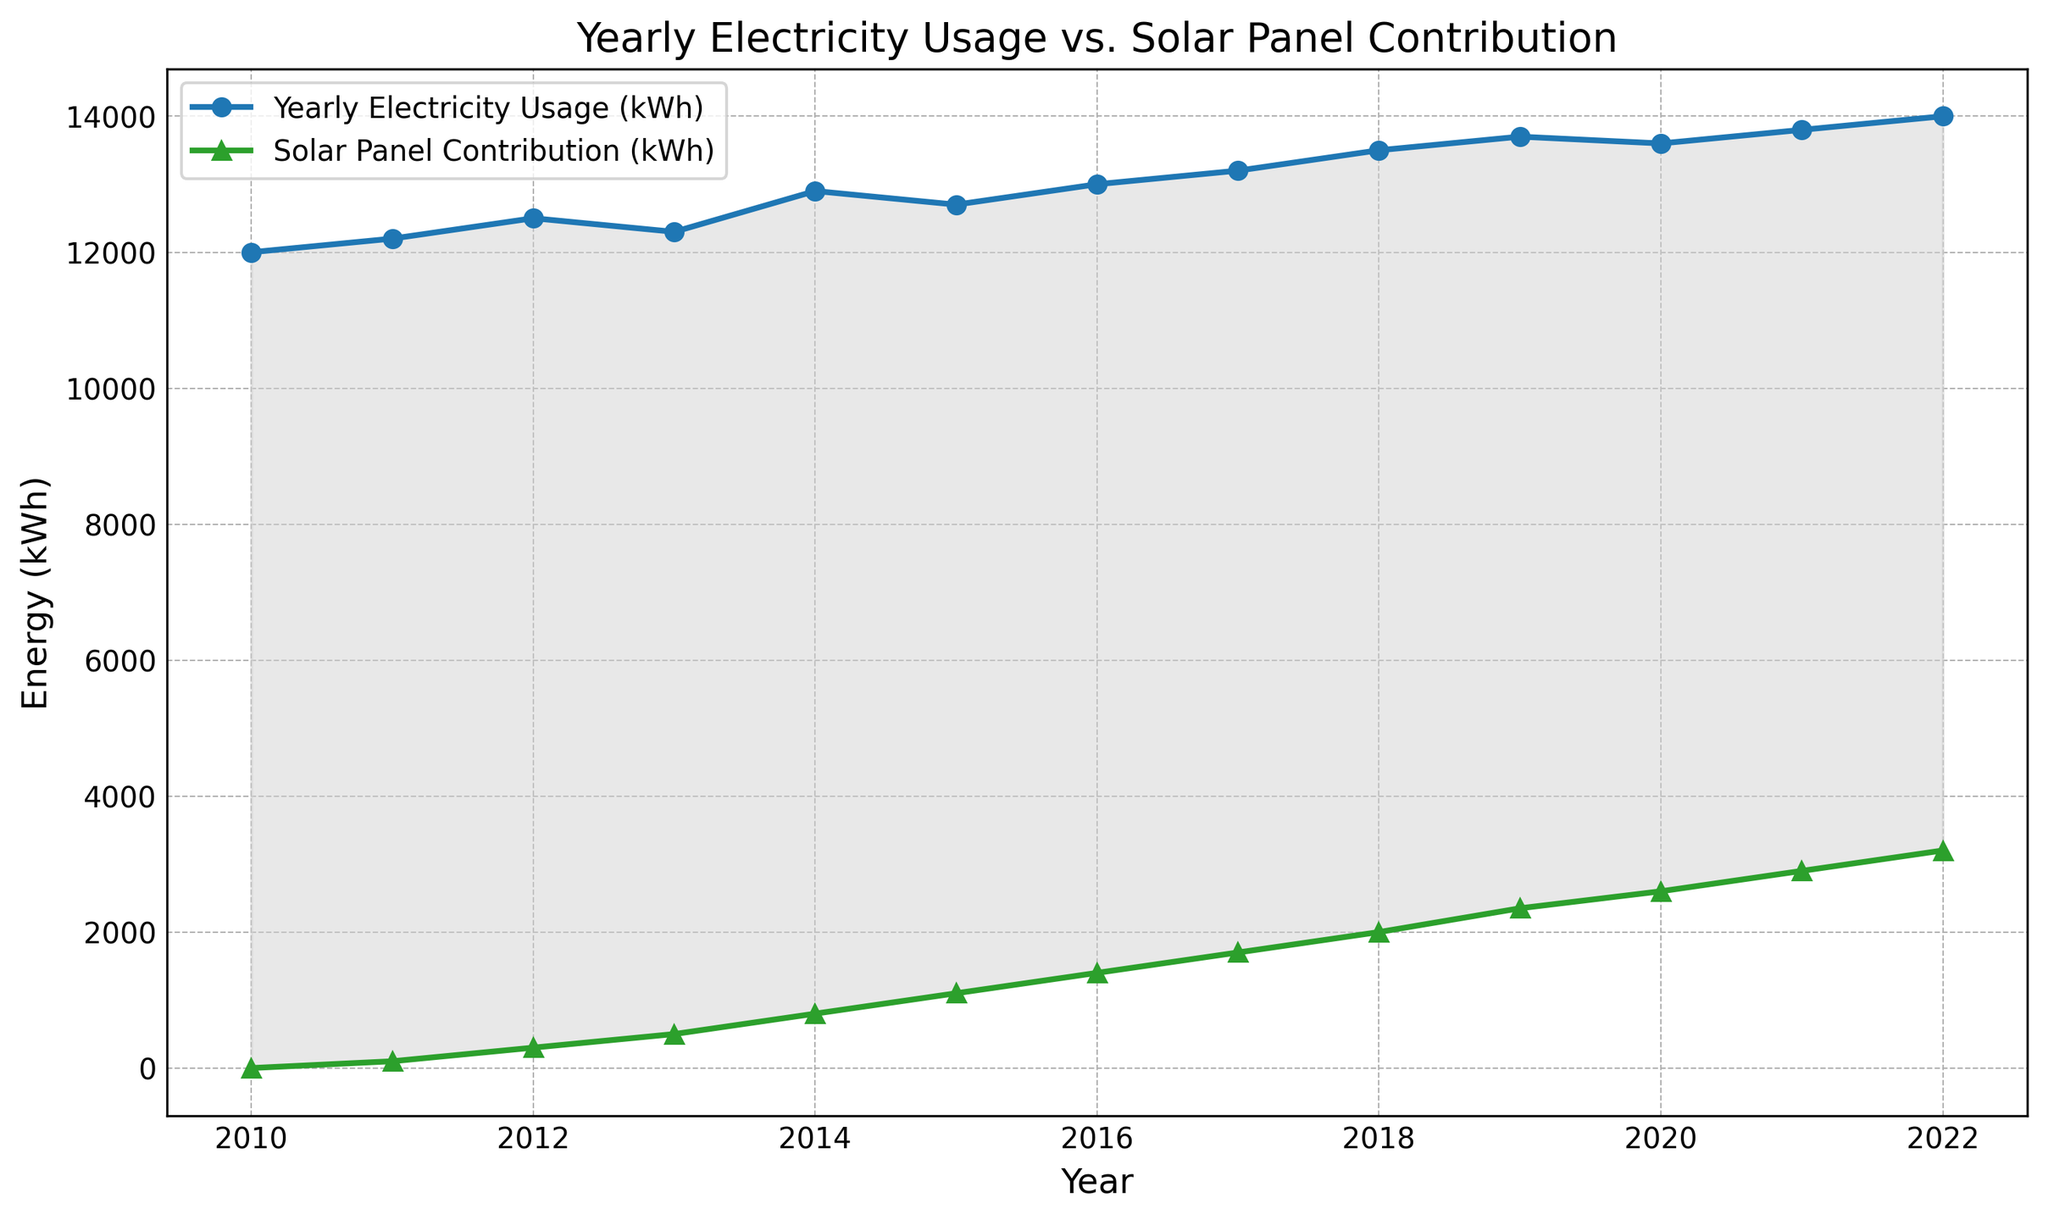What is the difference in Yearly Electricity Usage between 2010 and 2022? By observing the data points for 2010 (12000 kWh) and 2022 (14000 kWh) on the chart, we subtract 12000 from 14000 to find the difference.
Answer: 2000 kWh How did Solar Panel Contribution change from 2015 to 2018? Looking at the Solar Panel Contribution for 2015 (1100 kWh) and 2018 (2000 kWh) on the chart, subtract the 2015 value from the 2018 value.
Answer: Increased by 900 kWh In which year did the Solar Panel Contribution exceed 1000 kWh for the first time? By examining the Solar Panel Contribution line on the chart, 2015 is the first year when the contribution (1100 kWh) exceeds 1000 kWh.
Answer: 2015 What is the sum of Yearly Electricity Usage and Solar Panel Contribution for 2020? Add the Yearly Electricity Usage (13600 kWh) and Solar Panel Contribution (2600 kWh) for 2020.
Answer: 16200 kWh How does the trend of Yearly Electricity Usage compare to the trend of Solar Panel Contribution over the years? The Yearly Electricity Usage shows a generally increasing trend from 12000 kWh in 2010 to 14000 kWh in 2022, with some fluctuations. The Solar Panel Contribution shows a consistent upward trend from 0 kWh in 2010 to 3200 kWh in 2022.
Answer: Usage increases with fluctuations, Solar consistently increases In what year was the difference between Yearly Electricity Usage and Solar Panel Contribution the greatest? Observing the filled area between the two lines on the chart reveals that around 2010, the difference was the greatest because the contributions from solar panels were zero at that time.
Answer: 2010 What is the total increase in Solar Panel Contribution from 2010 to 2022? Subtract the Solar Panel Contribution in 2010 (0 kWh) from that in 2022 (3200 kWh).
Answer: 3200 kWh Which year had the smallest gap between Yearly Electricity Usage and Solar Panel Contribution, and what could be the reason? By looking at the filled area between the lines, 2022 had the smallest gap. This could be due to an increase in solar panel capacity and contributions over the years.
Answer: 2022 Is there any year where Yearly Electricity Usage decreased compared to the previous year? If so, which year? Observing the Yearly Electricity Usage trend, there is a decrease from 2019 (13700 kWh) to 2020 (13600 kWh).
Answer: 2020 How does the growth rate of Solar Panel Contribution compare to the Yearly Electricity Usage from 2010 to 2022? From 2010 to 2022, Solar Panel Contribution increased by 3200 kWh while Yearly Electricity Usage increased by 2000 kWh. The Solar Panel Contribution has a steeper upward trend compared to the more gradual increase in Yearly Electricity Usage.
Answer: Solar Contribution grows faster 